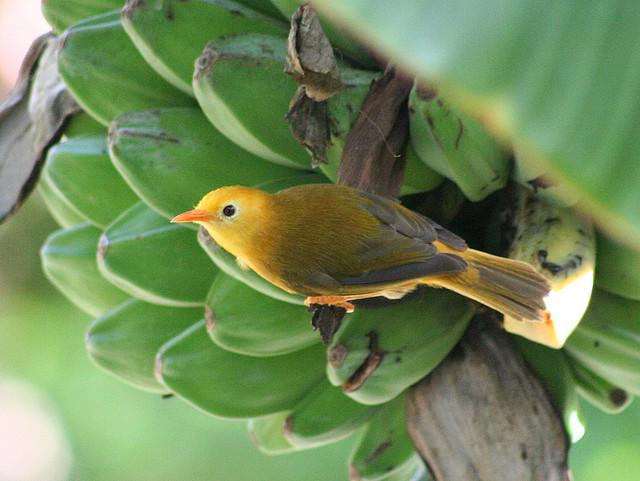What type of bird is this?
Give a very brief answer. Canary. Is the bird perched?
Answer briefly. Yes. What color is the bird?
Keep it brief. Yellow. 